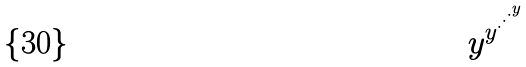Convert formula to latex. <formula><loc_0><loc_0><loc_500><loc_500>y ^ { y ^ { \cdot ^ { \cdot ^ { \cdot ^ { y } } } } }</formula> 